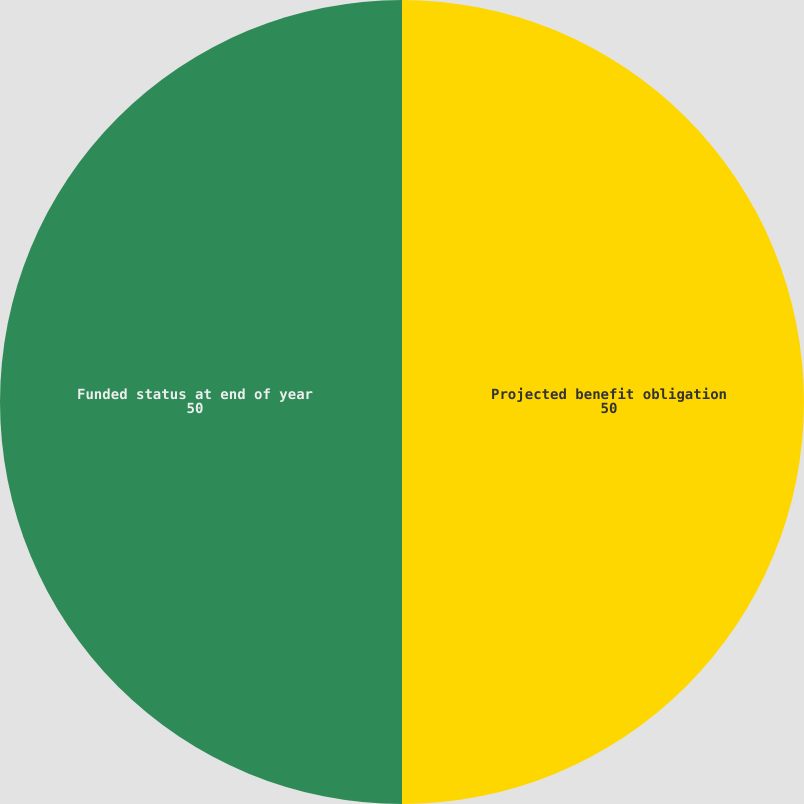Convert chart to OTSL. <chart><loc_0><loc_0><loc_500><loc_500><pie_chart><fcel>Projected benefit obligation<fcel>Funded status at end of year<nl><fcel>50.0%<fcel>50.0%<nl></chart> 